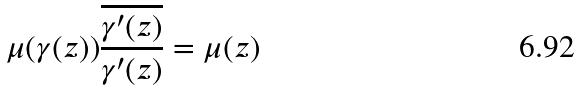<formula> <loc_0><loc_0><loc_500><loc_500>\mu ( \gamma ( z ) ) \frac { \overline { \gamma ^ { \prime } ( z ) } } { \gamma ^ { \prime } ( z ) } = \mu ( z )</formula> 